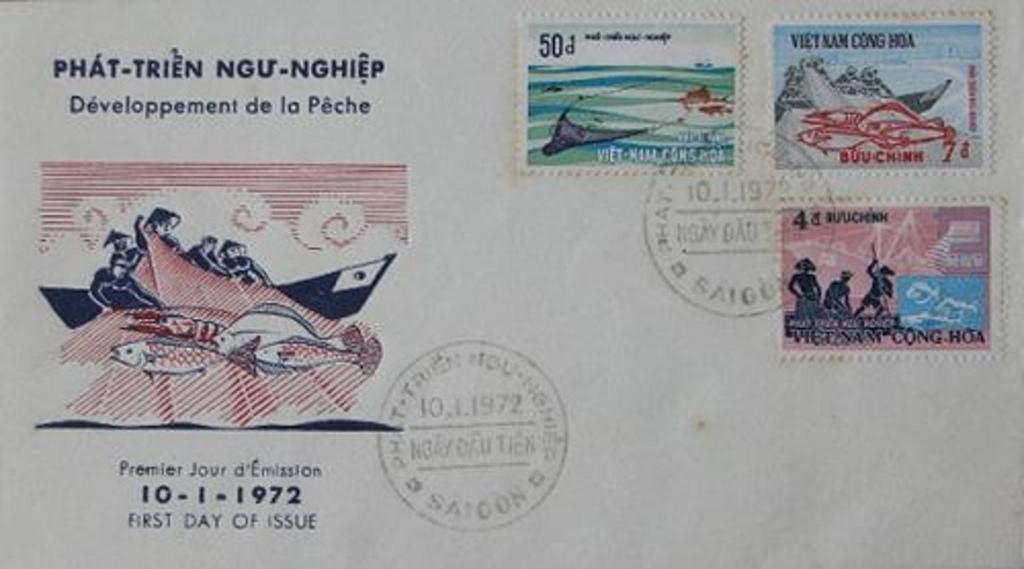What was the first day of issue?
Your answer should be very brief. 10-1-1972. What is the number in the round stamp on the envelope?
Provide a short and direct response. 10.1.1972. 